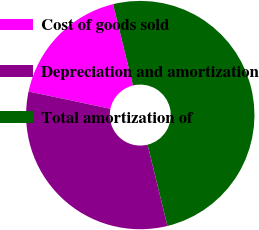Convert chart to OTSL. <chart><loc_0><loc_0><loc_500><loc_500><pie_chart><fcel>Cost of goods sold<fcel>Depreciation and amortization<fcel>Total amortization of<nl><fcel>17.86%<fcel>32.14%<fcel>50.0%<nl></chart> 